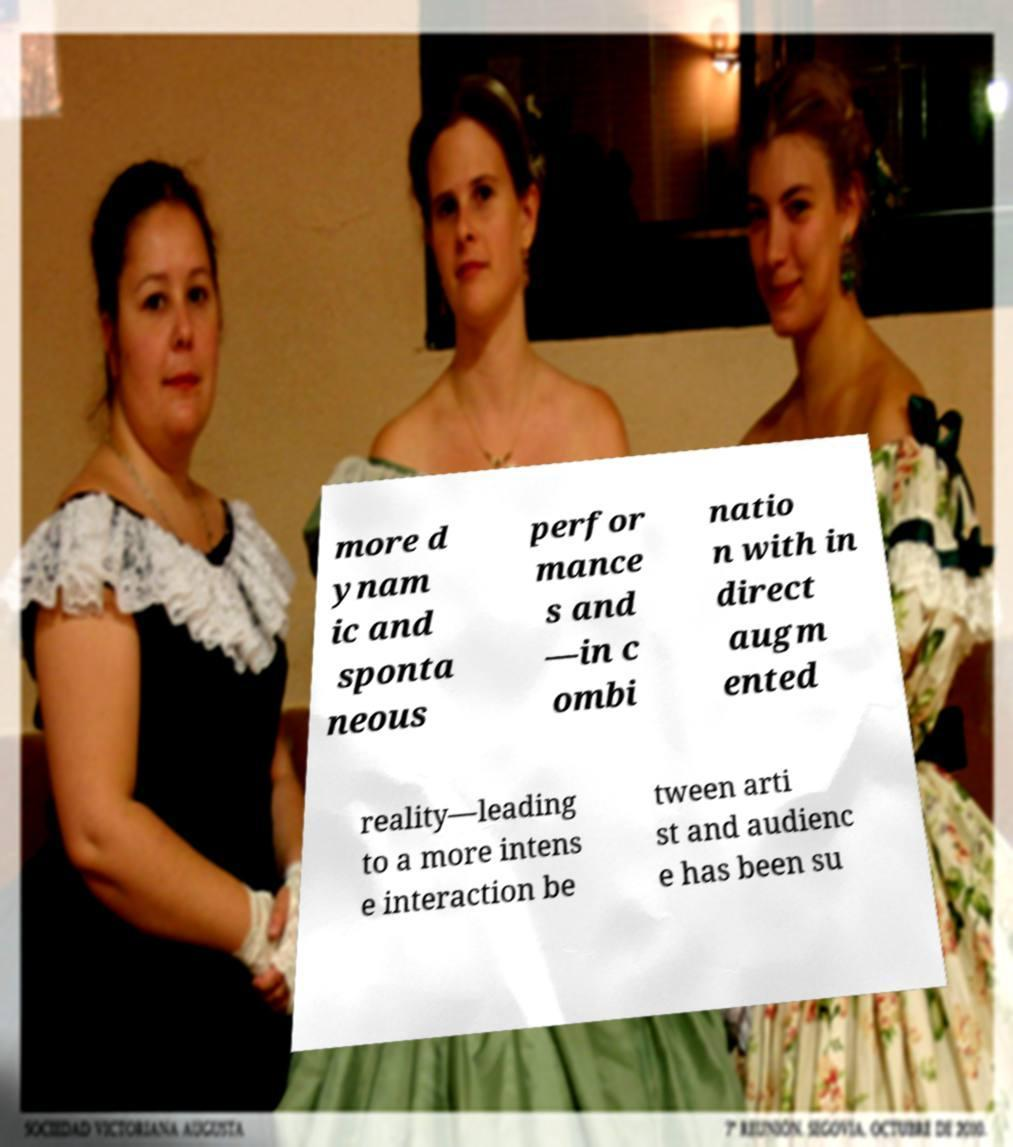Could you assist in decoding the text presented in this image and type it out clearly? more d ynam ic and sponta neous perfor mance s and —in c ombi natio n with in direct augm ented reality—leading to a more intens e interaction be tween arti st and audienc e has been su 